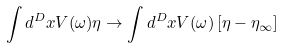<formula> <loc_0><loc_0><loc_500><loc_500>\int d ^ { D } x V ( \omega ) \eta \rightarrow \int d ^ { D } x V ( \omega ) \left [ \eta - \eta _ { \infty } \right ]</formula> 